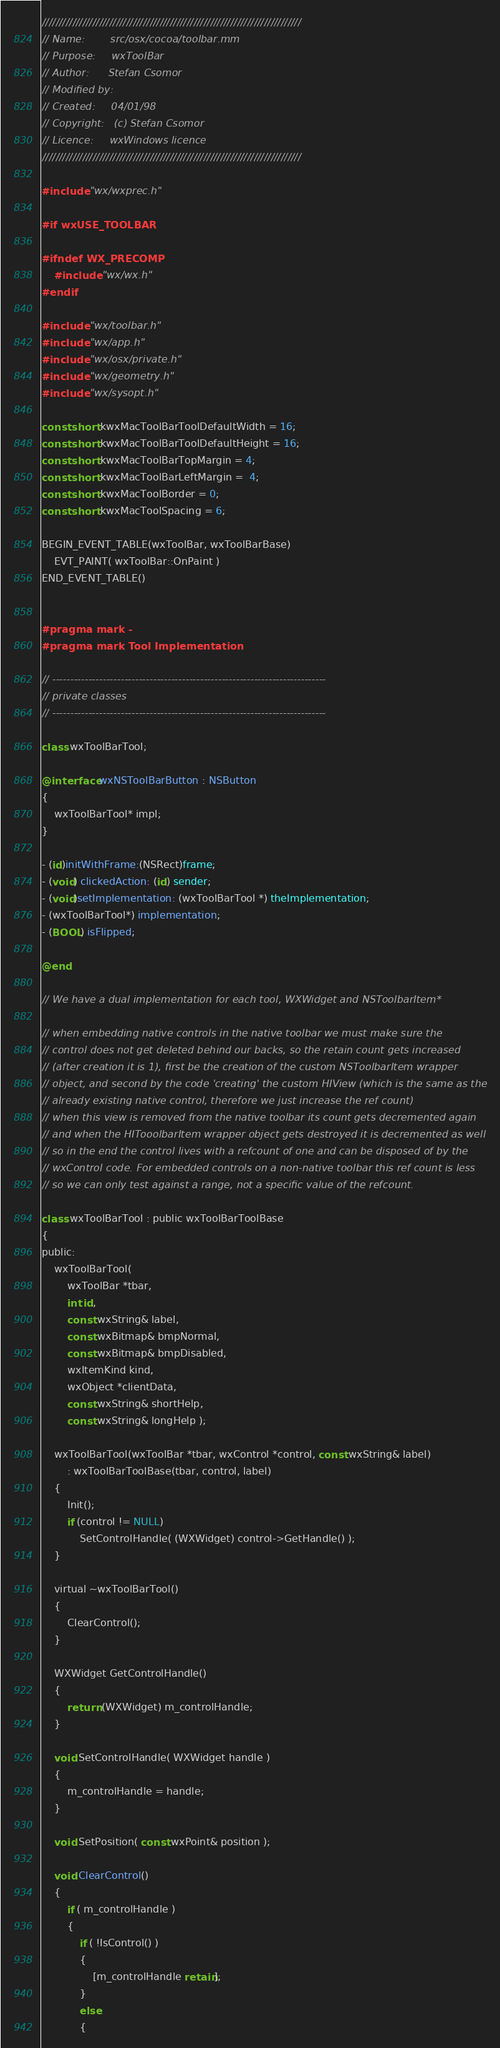Convert code to text. <code><loc_0><loc_0><loc_500><loc_500><_ObjectiveC_>/////////////////////////////////////////////////////////////////////////////
// Name:        src/osx/cocoa/toolbar.mm
// Purpose:     wxToolBar
// Author:      Stefan Csomor
// Modified by:
// Created:     04/01/98
// Copyright:   (c) Stefan Csomor
// Licence:     wxWindows licence
/////////////////////////////////////////////////////////////////////////////

#include "wx/wxprec.h"

#if wxUSE_TOOLBAR

#ifndef WX_PRECOMP
    #include "wx/wx.h"
#endif

#include "wx/toolbar.h"
#include "wx/app.h"
#include "wx/osx/private.h"
#include "wx/geometry.h"
#include "wx/sysopt.h"

const short kwxMacToolBarToolDefaultWidth = 16;
const short kwxMacToolBarToolDefaultHeight = 16;
const short kwxMacToolBarTopMargin = 4;
const short kwxMacToolBarLeftMargin =  4;
const short kwxMacToolBorder = 0;
const short kwxMacToolSpacing = 6;

BEGIN_EVENT_TABLE(wxToolBar, wxToolBarBase)
    EVT_PAINT( wxToolBar::OnPaint )
END_EVENT_TABLE()


#pragma mark -
#pragma mark Tool Implementation

// ----------------------------------------------------------------------------
// private classes
// ----------------------------------------------------------------------------

class wxToolBarTool;

@interface wxNSToolBarButton : NSButton
{
    wxToolBarTool* impl;
}

- (id)initWithFrame:(NSRect)frame;
- (void) clickedAction: (id) sender;
- (void)setImplementation: (wxToolBarTool *) theImplementation;
- (wxToolBarTool*) implementation;
- (BOOL) isFlipped;

@end

// We have a dual implementation for each tool, WXWidget and NSToolbarItem*

// when embedding native controls in the native toolbar we must make sure the
// control does not get deleted behind our backs, so the retain count gets increased
// (after creation it is 1), first be the creation of the custom NSToolbarItem wrapper
// object, and second by the code 'creating' the custom HIView (which is the same as the
// already existing native control, therefore we just increase the ref count)
// when this view is removed from the native toolbar its count gets decremented again
// and when the HITooolbarItem wrapper object gets destroyed it is decremented as well
// so in the end the control lives with a refcount of one and can be disposed of by the
// wxControl code. For embedded controls on a non-native toolbar this ref count is less
// so we can only test against a range, not a specific value of the refcount.

class wxToolBarTool : public wxToolBarToolBase
{
public:
    wxToolBarTool(
        wxToolBar *tbar,
        int id,
        const wxString& label,
        const wxBitmap& bmpNormal,
        const wxBitmap& bmpDisabled,
        wxItemKind kind,
        wxObject *clientData,
        const wxString& shortHelp,
        const wxString& longHelp );

    wxToolBarTool(wxToolBar *tbar, wxControl *control, const wxString& label)
        : wxToolBarToolBase(tbar, control, label)
    {
        Init();
        if (control != NULL)
            SetControlHandle( (WXWidget) control->GetHandle() );
    }

    virtual ~wxToolBarTool()
    {
        ClearControl();
    }

    WXWidget GetControlHandle()
    {
        return (WXWidget) m_controlHandle;
    }

    void SetControlHandle( WXWidget handle )
    {
        m_controlHandle = handle;
    }

    void SetPosition( const wxPoint& position );

    void ClearControl()
    {
        if ( m_controlHandle )
        {
            if ( !IsControl() )
            {
                [m_controlHandle retain];
            }
            else
            {</code> 